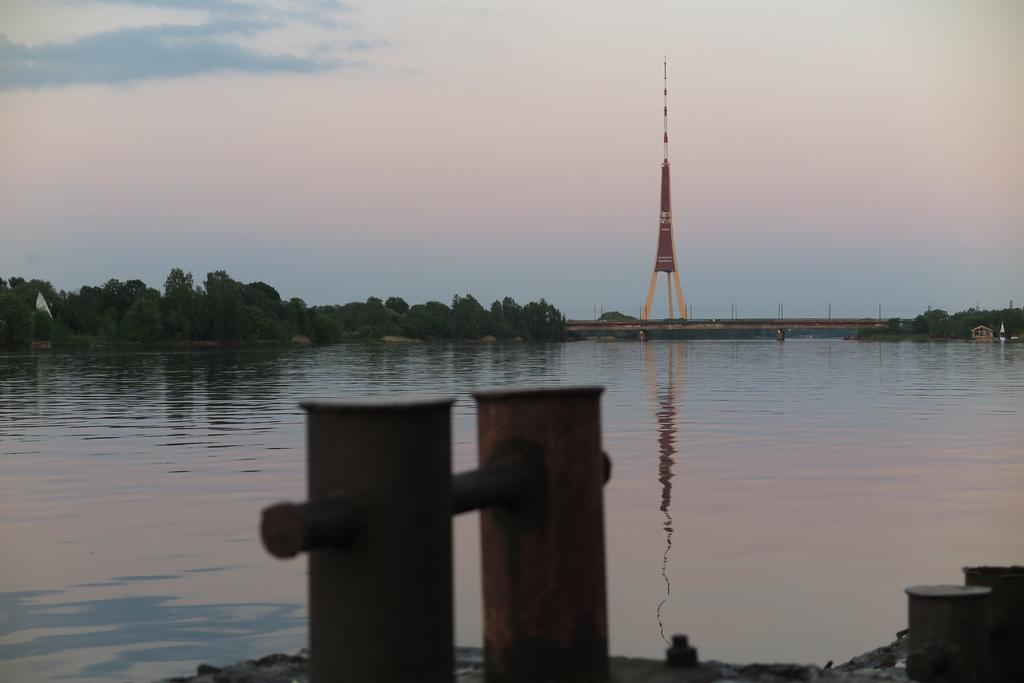What object is the main focus of the image? There is a pot in the image. What other structure can be seen in the image? There is a signal tower in the image. What type of natural elements are visible in the image? There are trees visible in the image. What type of coat is the pot wearing in the image? The pot is not wearing a coat, as it is an inanimate object and does not have the ability to wear clothing. 